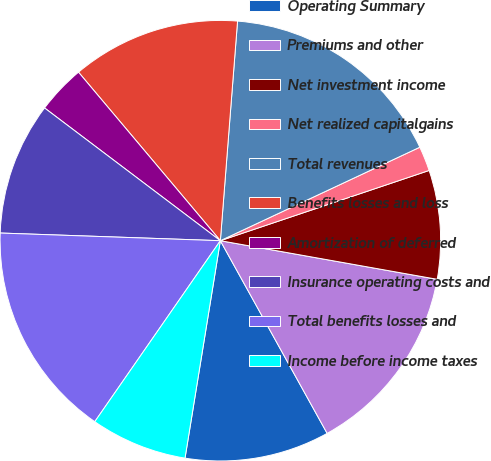Convert chart to OTSL. <chart><loc_0><loc_0><loc_500><loc_500><pie_chart><fcel>Operating Summary<fcel>Premiums and other<fcel>Net investment income<fcel>Net realized capitalgains<fcel>Total revenues<fcel>Benefits losses and loss<fcel>Amortization of deferred<fcel>Insurance operating costs and<fcel>Total benefits losses and<fcel>Income before income taxes<nl><fcel>10.62%<fcel>14.14%<fcel>7.97%<fcel>1.81%<fcel>16.78%<fcel>12.38%<fcel>3.57%<fcel>9.74%<fcel>15.9%<fcel>7.09%<nl></chart> 